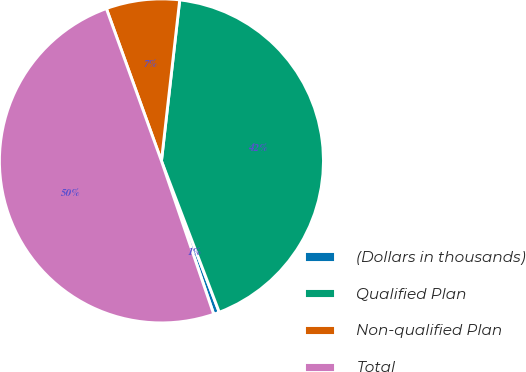Convert chart. <chart><loc_0><loc_0><loc_500><loc_500><pie_chart><fcel>(Dollars in thousands)<fcel>Qualified Plan<fcel>Non-qualified Plan<fcel>Total<nl><fcel>0.58%<fcel>42.39%<fcel>7.32%<fcel>49.71%<nl></chart> 